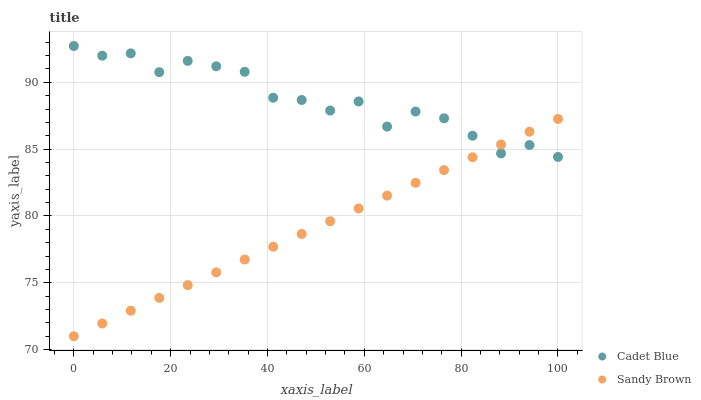Does Sandy Brown have the minimum area under the curve?
Answer yes or no. Yes. Does Cadet Blue have the maximum area under the curve?
Answer yes or no. Yes. Does Sandy Brown have the maximum area under the curve?
Answer yes or no. No. Is Sandy Brown the smoothest?
Answer yes or no. Yes. Is Cadet Blue the roughest?
Answer yes or no. Yes. Is Sandy Brown the roughest?
Answer yes or no. No. Does Sandy Brown have the lowest value?
Answer yes or no. Yes. Does Cadet Blue have the highest value?
Answer yes or no. Yes. Does Sandy Brown have the highest value?
Answer yes or no. No. Does Cadet Blue intersect Sandy Brown?
Answer yes or no. Yes. Is Cadet Blue less than Sandy Brown?
Answer yes or no. No. Is Cadet Blue greater than Sandy Brown?
Answer yes or no. No. 